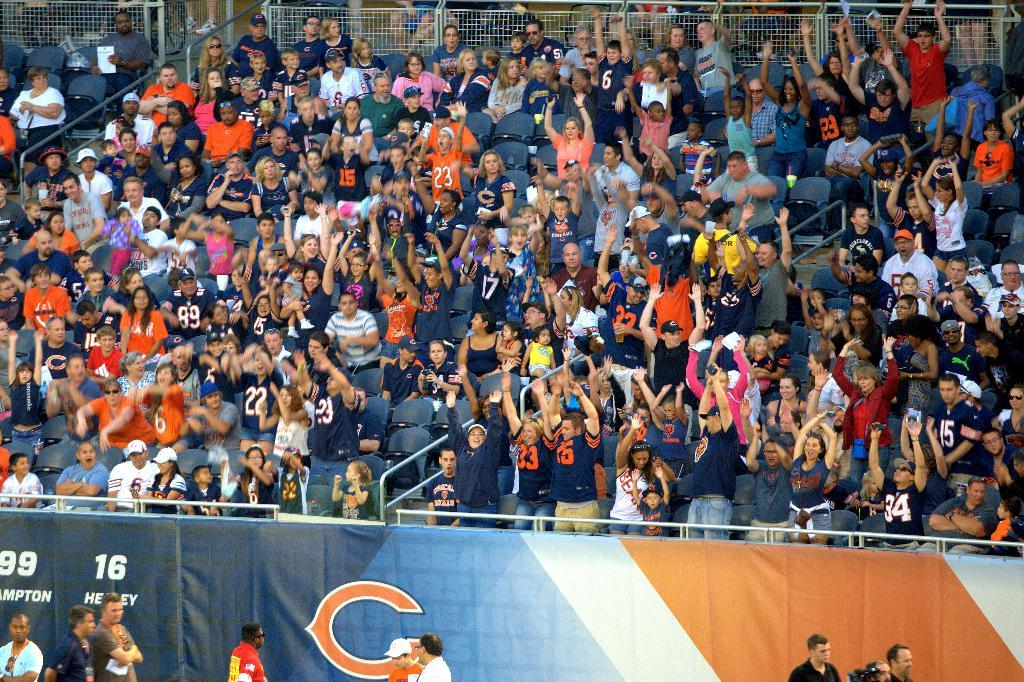What are the people in the image doing? There are groups of people sitting on chairs and people standing in the image. What can be seen that might be used for crowd control or separation? There are barricades visible in the image. What type of signage is present in the image? There is a hoarding in the image. What type of barrier can be seen in the image? There is a fence in the image. What is the distance between the birth of the first person and the last person in the image? There is no information about the birth of any person in the image, so it is not possible to determine the distance between their births. 